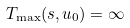Convert formula to latex. <formula><loc_0><loc_0><loc_500><loc_500>T _ { \max } ( s , u _ { 0 } ) = \infty</formula> 